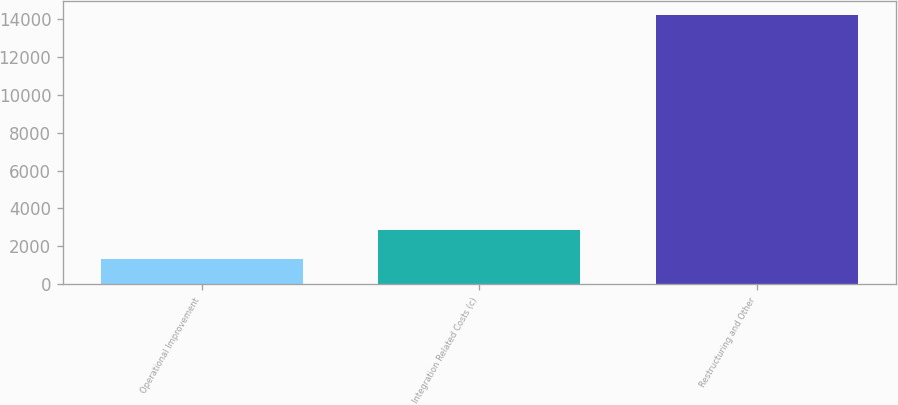Convert chart to OTSL. <chart><loc_0><loc_0><loc_500><loc_500><bar_chart><fcel>Operational Improvement<fcel>Integration Related Costs (c)<fcel>Restructuring and Other<nl><fcel>1352<fcel>2848<fcel>14246<nl></chart> 